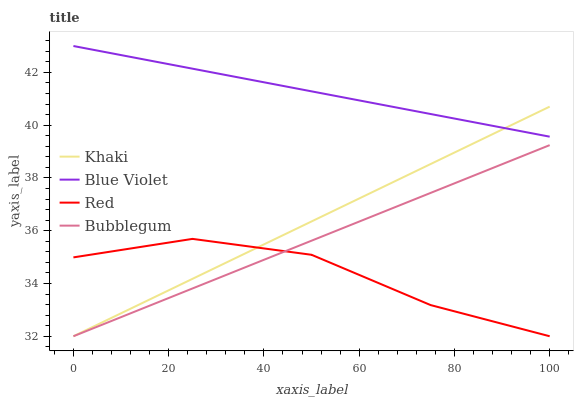Does Red have the minimum area under the curve?
Answer yes or no. Yes. Does Blue Violet have the maximum area under the curve?
Answer yes or no. Yes. Does Khaki have the minimum area under the curve?
Answer yes or no. No. Does Khaki have the maximum area under the curve?
Answer yes or no. No. Is Bubblegum the smoothest?
Answer yes or no. Yes. Is Red the roughest?
Answer yes or no. Yes. Is Khaki the smoothest?
Answer yes or no. No. Is Khaki the roughest?
Answer yes or no. No. Does Bubblegum have the lowest value?
Answer yes or no. Yes. Does Blue Violet have the lowest value?
Answer yes or no. No. Does Blue Violet have the highest value?
Answer yes or no. Yes. Does Khaki have the highest value?
Answer yes or no. No. Is Red less than Blue Violet?
Answer yes or no. Yes. Is Blue Violet greater than Red?
Answer yes or no. Yes. Does Khaki intersect Bubblegum?
Answer yes or no. Yes. Is Khaki less than Bubblegum?
Answer yes or no. No. Is Khaki greater than Bubblegum?
Answer yes or no. No. Does Red intersect Blue Violet?
Answer yes or no. No. 